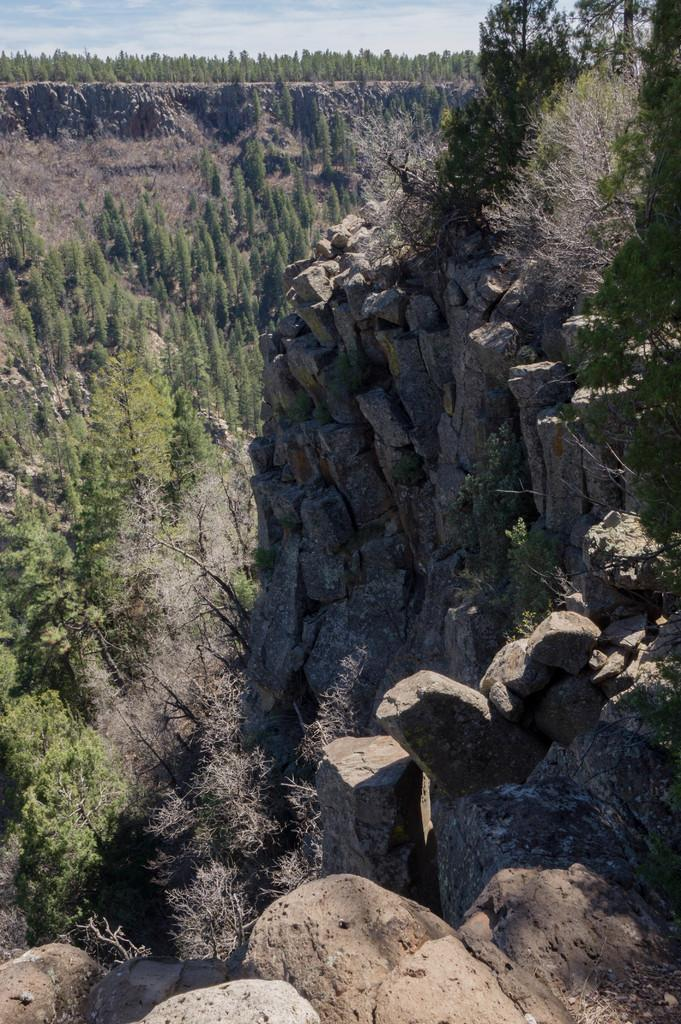What type of natural elements can be seen in the image? There are rocks, plants, and trees in the image. What is visible in the background of the image? The sky is visible in the background of the image. How many snails can be seen climbing on the rocks in the image? There are no snails present in the image; it only features rocks, plants, trees, and the sky. What part of the nation is depicted in the image? The image does not depict a specific part of a nation; it simply shows natural elements such as rocks, plants, trees, and the sky. 